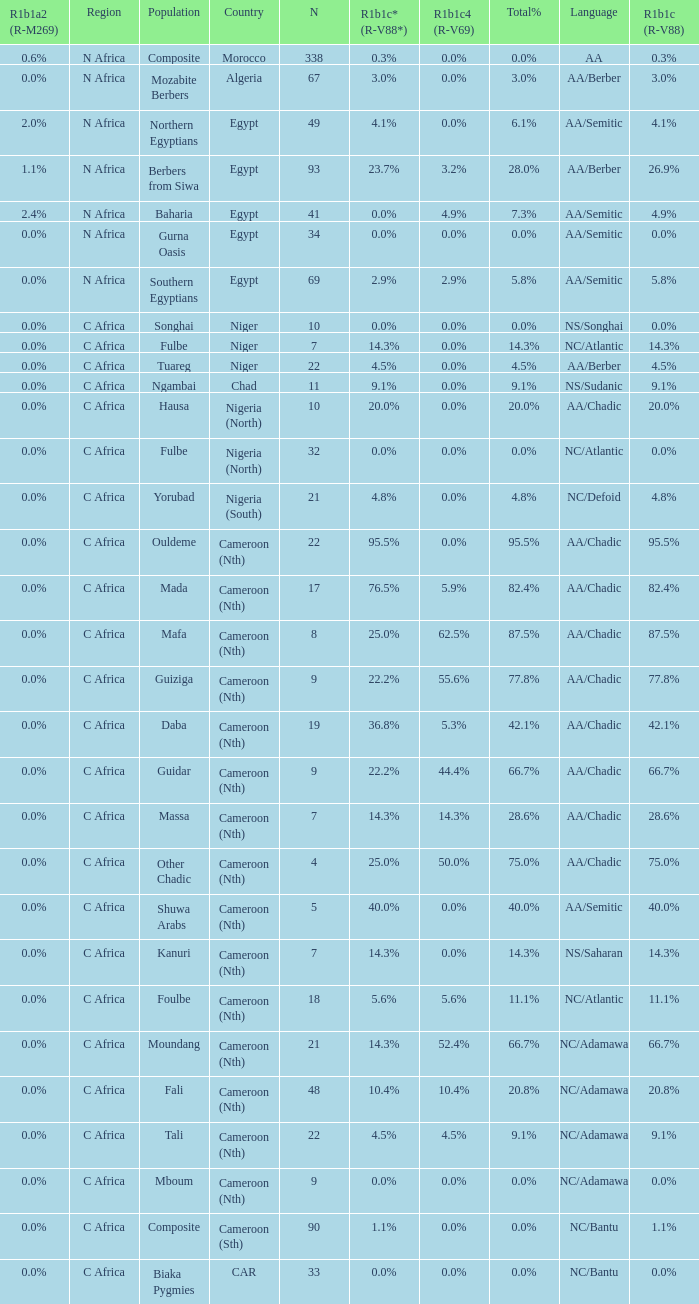What is the largest n value for 55.6% r1b1c4 (r-v69)? 9.0. 